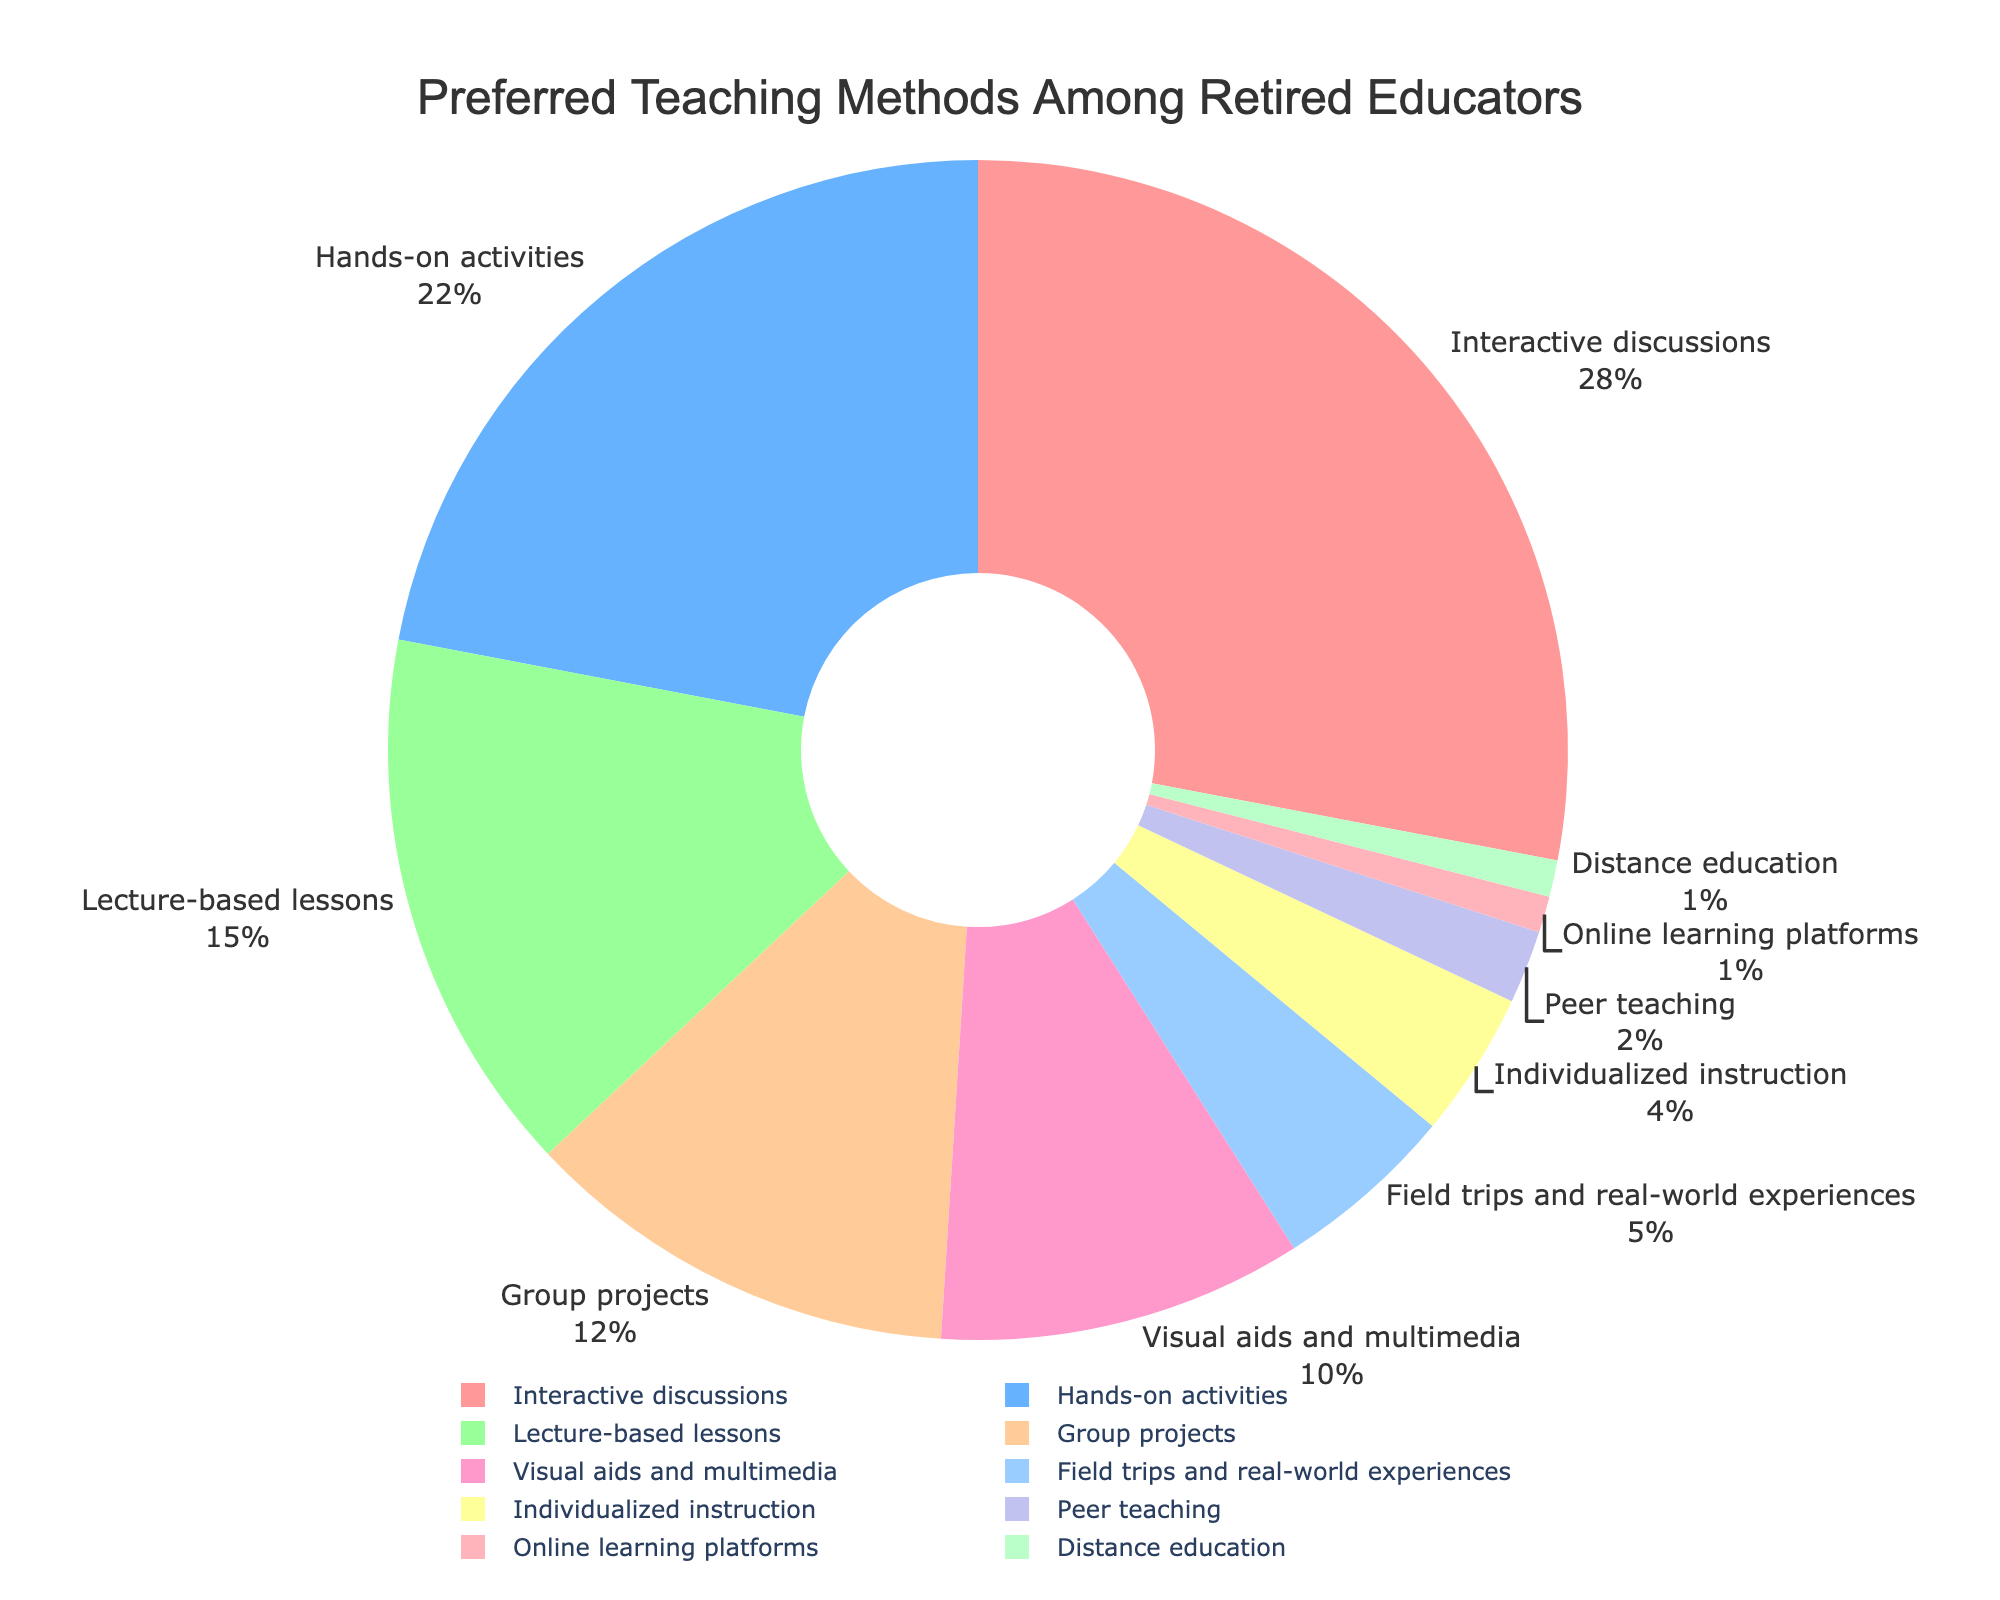Which teaching method is the most preferred among retired educators? The pie chart shows that 'Interactive discussions' has the largest section with a percentage of 28%, indicating it is the most preferred teaching method.
Answer: Interactive discussions Which teaching method is least preferred among retired educators? The smallest sections of the pie chart, both with a percentage of 1%, are 'Online learning platforms' and 'Distance education', indicating they are the least preferred methods.
Answer: Online learning platforms and Distance education What is the combined percentage for 'Hands-on activities' and 'Group projects'? 'Hands-on activities' has a percentage of 22% and 'Group projects' has a percentage of 12%. Adding these together gives 22% + 12% = 34%.
Answer: 34% How many teaching methods have a percentage higher than 10%? Scanning through the pie chart, the methods with more than 10% are: 'Interactive discussions' (28%), 'Hands-on activities' (22%), 'Lecture-based lessons' (15%), and 'Group projects' (12%). That's a total of 4 methods.
Answer: 4 Is 'Lecture-based lessons' more preferred than 'Visual aids and multimedia'? 'Lecture-based lessons' has a percentage of 15% while 'Visual aids and multimedia' has 10%. Since 15% is greater than 10%, 'Lecture-based lessons' is more preferred.
Answer: Yes What is the difference in percentage between 'Field trips and real-world experiences' and 'Individualized instruction'? 'Field trips and real-world experiences' has a percentage of 5% and 'Individualized instruction' has 4%. Subtracting these gives 5% - 4% = 1%.
Answer: 1% What is the percentage representation of methods preferred by at least 20% of retired educators? Only 'Interactive discussions' and 'Hands-on activities' have percentages of at least 20%, with 28% and 22% respectively. Adding these gives 28% + 22% = 50%.
Answer: 50% Which teaching method is represented by a red color on the pie chart? The color red corresponds to the section with the label 'Interactive discussions' at 28%.
Answer: Interactive discussions Among the methods, which comes immediately before 'Distance education' in the legend below the pie chart? Scanning the legend, 'Peer teaching' with 2% comes immediately before 'Distance education' (1%).
Answer: Peer teaching 